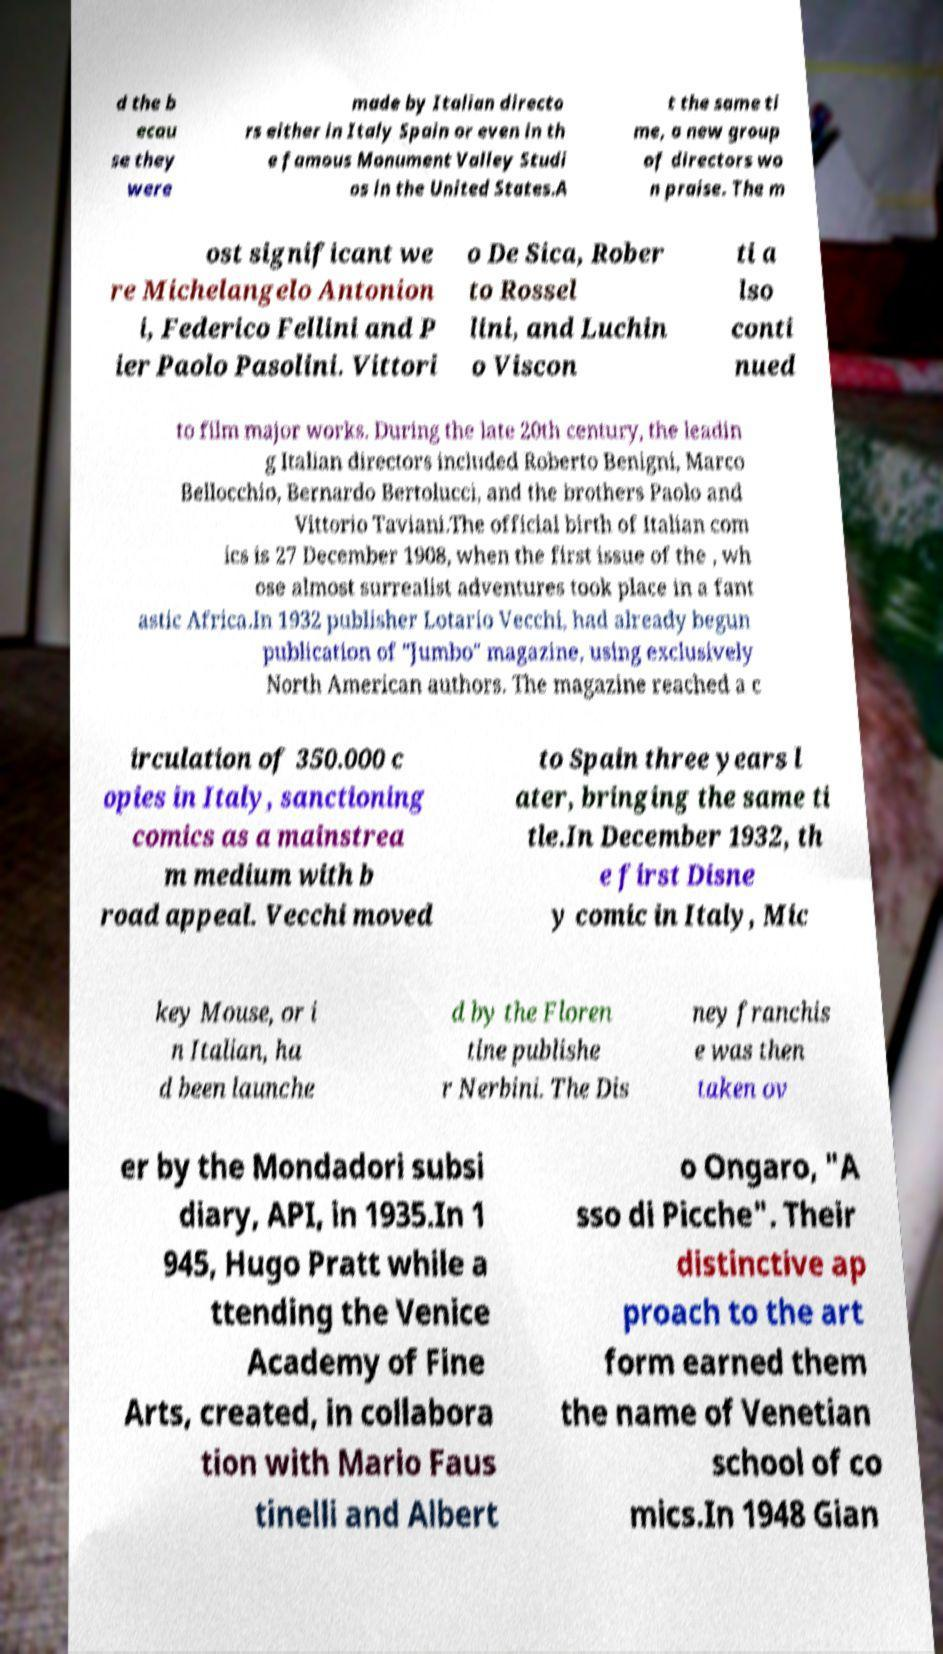Please identify and transcribe the text found in this image. d the b ecau se they were made by Italian directo rs either in Italy Spain or even in th e famous Monument Valley Studi os in the United States.A t the same ti me, a new group of directors wo n praise. The m ost significant we re Michelangelo Antonion i, Federico Fellini and P ier Paolo Pasolini. Vittori o De Sica, Rober to Rossel lini, and Luchin o Viscon ti a lso conti nued to film major works. During the late 20th century, the leadin g Italian directors included Roberto Benigni, Marco Bellocchio, Bernardo Bertolucci, and the brothers Paolo and Vittorio Taviani.The official birth of Italian com ics is 27 December 1908, when the first issue of the , wh ose almost surrealist adventures took place in a fant astic Africa.In 1932 publisher Lotario Vecchi, had already begun publication of "Jumbo" magazine, using exclusively North American authors. The magazine reached a c irculation of 350.000 c opies in Italy, sanctioning comics as a mainstrea m medium with b road appeal. Vecchi moved to Spain three years l ater, bringing the same ti tle.In December 1932, th e first Disne y comic in Italy, Mic key Mouse, or i n Italian, ha d been launche d by the Floren tine publishe r Nerbini. The Dis ney franchis e was then taken ov er by the Mondadori subsi diary, API, in 1935.In 1 945, Hugo Pratt while a ttending the Venice Academy of Fine Arts, created, in collabora tion with Mario Faus tinelli and Albert o Ongaro, "A sso di Picche". Their distinctive ap proach to the art form earned them the name of Venetian school of co mics.In 1948 Gian 